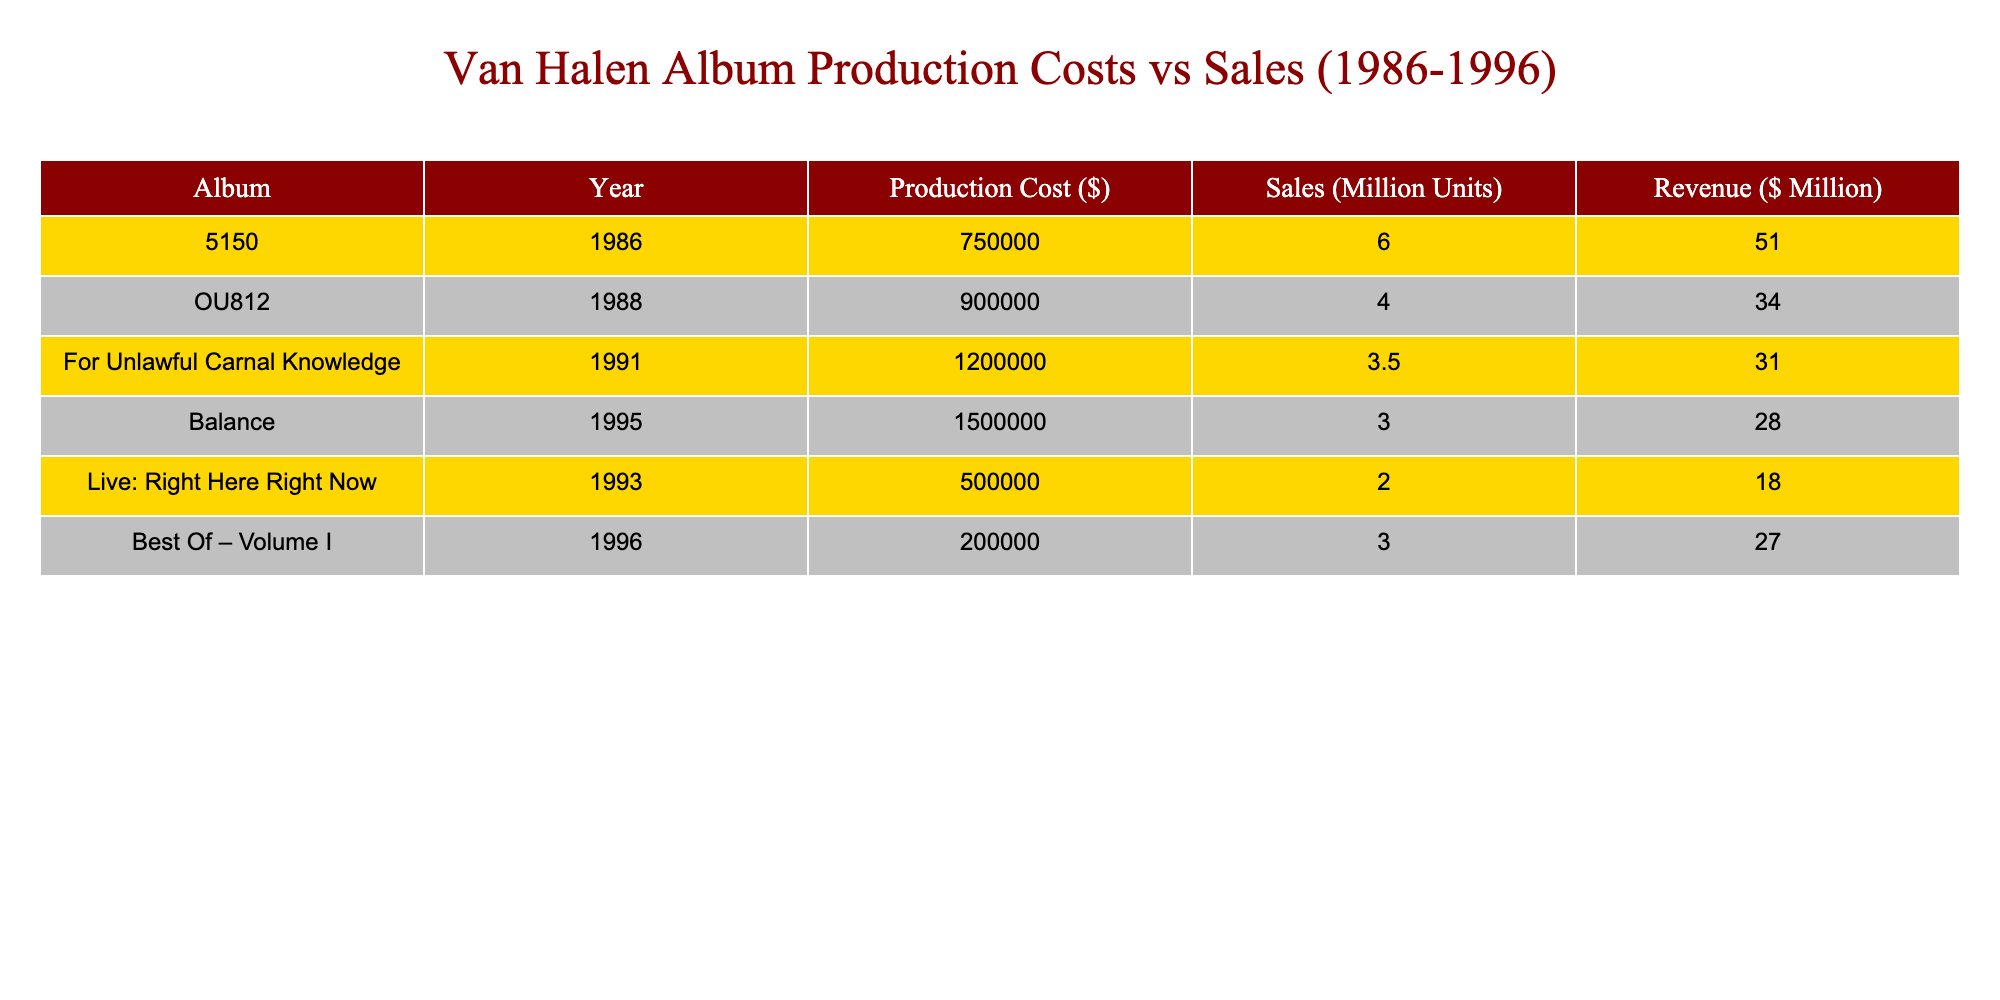What was the production cost of the album "OU812"? The table shows that the production cost for "OU812" is listed as $900,000.
Answer: $900,000 Which album had the highest sales figure? By examining the sales figures, "5150" has the highest sales at 6 million units.
Answer: 5150 What is the total production cost of all albums listed? To find the total production cost, sum the production costs: 750000 + 900000 + 1200000 + 1500000 + 500000 + 200000 = 5,100,000.
Answer: $5,100,000 Which album had the lowest revenue, and what was it? The lowest revenue is associated with "Balance," which earned $28 million.
Answer: Balance, $28 million What is the average sales figure of the albums produced between 1986 and 1996? To calculate the average sales, add all sales figures: 6 + 4 + 3.5 + 3 + 2 + 3 = 21.5 million units, then divide by 6 (total albums): 21.5/6 = 3.58 million units.
Answer: 3.58 million units Is it true that "For Unlawful Carnal Knowledge" had a production cost higher than its revenue? The production cost for "For Unlawful Carnal Knowledge" is $1,200,000 and its revenue is $31 million, so this statement is false.
Answer: No Which two albums had sales figures below 4 million units? The albums "OU812" and "For Unlawful Carnal Knowledge" both had sales figures below 4 million units.
Answer: OU812, For Unlawful Carnal Knowledge What is the difference between the production cost of "Balance" and "Best Of – Volume I"? The production cost for "Balance" is $1,500,000 and for "Best Of – Volume I" is $200,000. The difference is 1,500,000 - 200,000 = 1,300,000.
Answer: $1,300,000 Which album had the highest production cost, and how much was it? The album "Balance" had the highest production cost amounting to $1,500,000.
Answer: Balance, $1,500,000 What percentage of production costs for "5150" does its revenue represent? The revenue for "5150" is $51 million, and its production cost is $750,000. First, find the ratio: 750,000 / 51,000,000 = 0.0147. To find the percentage: 0.0147 * 100 = 1.47%.
Answer: 1.47% 